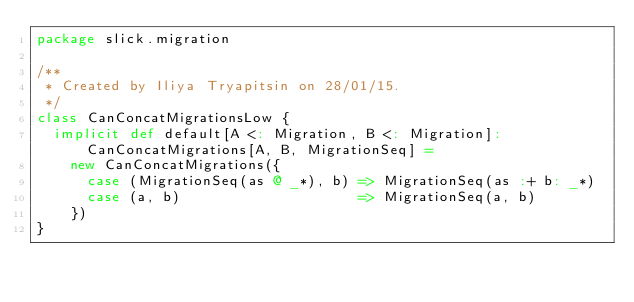Convert code to text. <code><loc_0><loc_0><loc_500><loc_500><_Scala_>package slick.migration

/**
 * Created by Iliya Tryapitsin on 28/01/15.
 */
class CanConcatMigrationsLow {
  implicit def default[A <: Migration, B <: Migration]: CanConcatMigrations[A, B, MigrationSeq] =
    new CanConcatMigrations({
      case (MigrationSeq(as @ _*), b) => MigrationSeq(as :+ b: _*)
      case (a, b)                     => MigrationSeq(a, b)
    })
}
</code> 